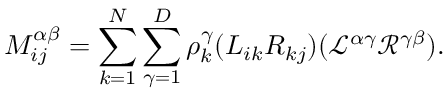<formula> <loc_0><loc_0><loc_500><loc_500>M _ { i j } ^ { \alpha \beta } = \sum _ { k = 1 } ^ { N } \sum _ { \gamma = 1 } ^ { D } \rho _ { k } ^ { \gamma } ( L _ { i k } R _ { k j } ) ( \mathcal { L } ^ { \alpha \gamma } \mathcal { R } ^ { \gamma \beta } ) .</formula> 